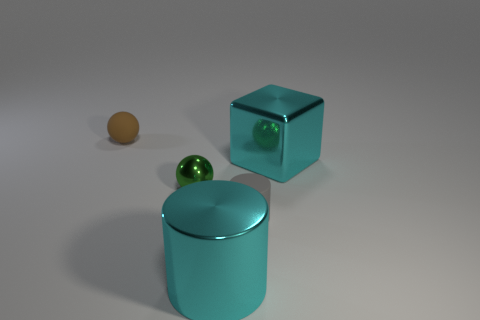What material is the green thing that is on the left side of the large cyan shiny thing that is in front of the tiny gray thing?
Provide a short and direct response. Metal. There is a cylinder that is the same size as the cyan metallic cube; what is its material?
Provide a short and direct response. Metal. There is a ball in front of the brown ball; is it the same size as the tiny cylinder?
Offer a terse response. Yes. Do the large cyan metallic object that is behind the small gray rubber cylinder and the small shiny thing have the same shape?
Ensure brevity in your answer.  No. What number of objects are large red rubber things or rubber balls that are behind the green object?
Make the answer very short. 1. Is the number of small gray rubber things less than the number of red objects?
Your answer should be very brief. No. Is the number of green spheres greater than the number of big things?
Offer a terse response. No. How many other objects are the same material as the small cylinder?
Give a very brief answer. 1. There is a large metal object in front of the cyan metal object behind the cyan cylinder; what number of small gray cylinders are left of it?
Offer a terse response. 0. How many metal things are brown cubes or small cylinders?
Make the answer very short. 0. 